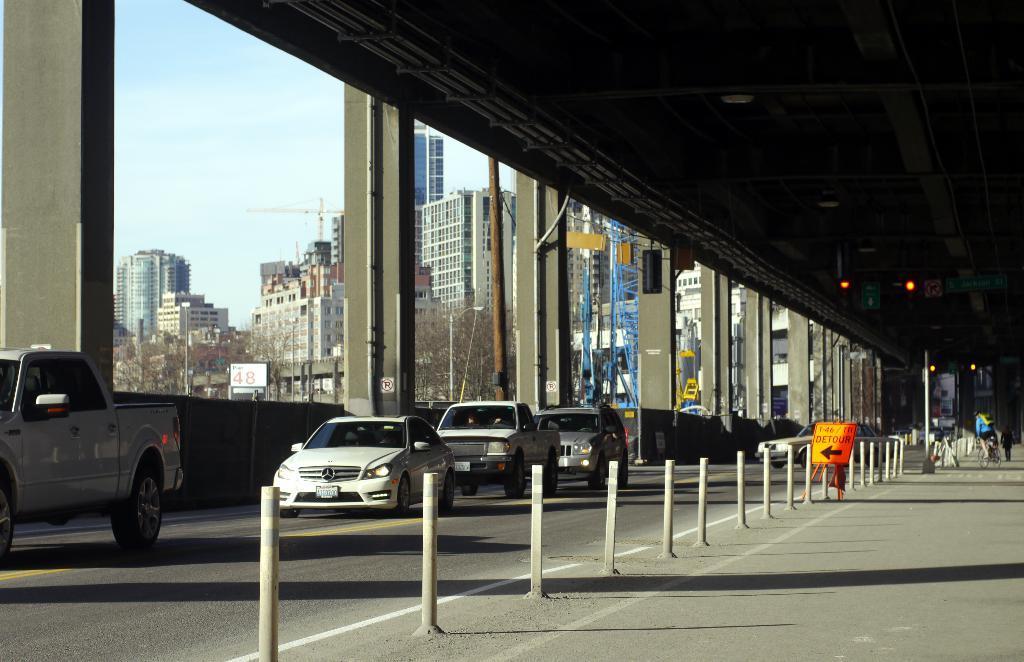How would you summarize this image in a sentence or two? In this image, we can see few vehicles are moving on the road. Here we can see poles, board, few people. Here a person is riding a bicycle. Background i can see pillars, buildings, cranes, trees, poles and sky. On the right side of the image, we can see few lights and sign boards. 